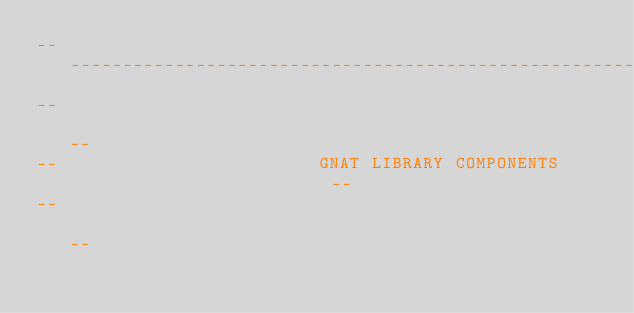Convert code to text. <code><loc_0><loc_0><loc_500><loc_500><_Ada_>------------------------------------------------------------------------------
--                                                                          --
--                         GNAT LIBRARY COMPONENTS                          --
--                                                                          --</code> 